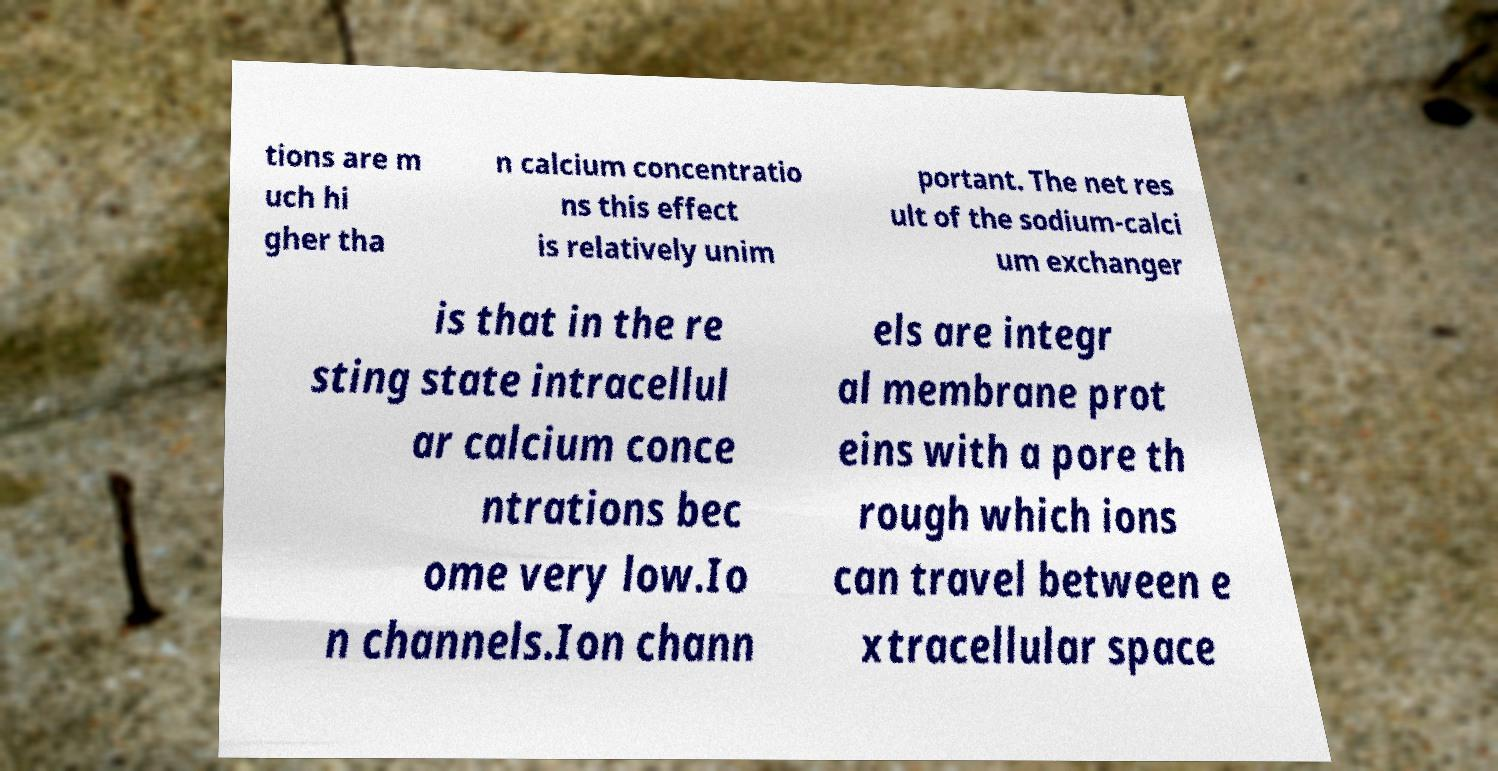There's text embedded in this image that I need extracted. Can you transcribe it verbatim? tions are m uch hi gher tha n calcium concentratio ns this effect is relatively unim portant. The net res ult of the sodium-calci um exchanger is that in the re sting state intracellul ar calcium conce ntrations bec ome very low.Io n channels.Ion chann els are integr al membrane prot eins with a pore th rough which ions can travel between e xtracellular space 